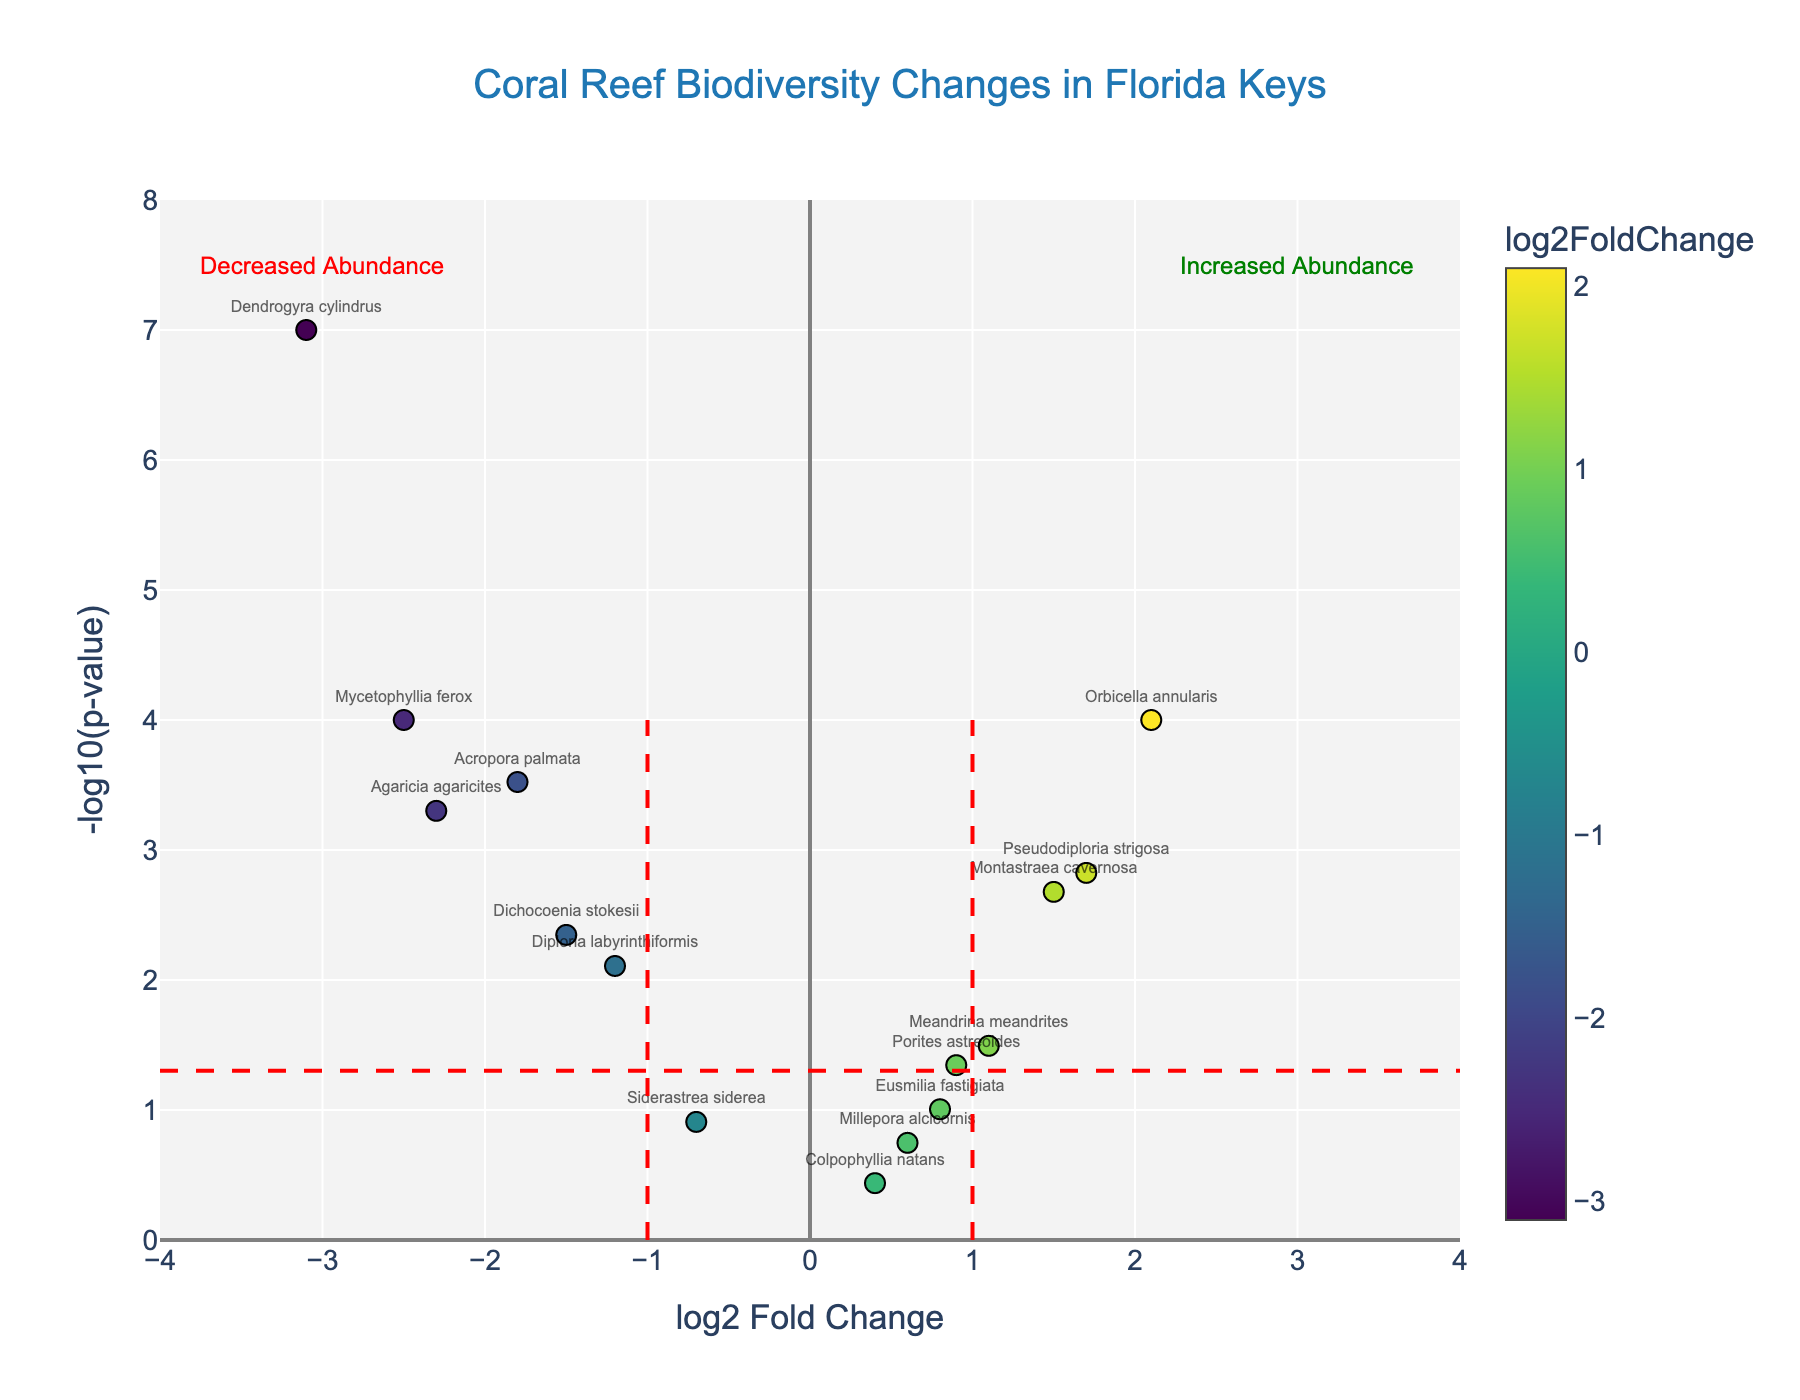What is the title of the figure? The title of the figure is typically located at the top and is displayed prominently to provide an overview of the subject being analyzed.
Answer: Coral Reef Biodiversity Changes in Florida Keys What is the log2 fold change value for Orbicella annularis? To find the log2 fold change value, locate the species 'Orbicella annularis' and refer to its corresponding log2FoldChange value.
Answer: 2.1 Which species has the highest -log10(p-value)? To determine the species with the highest -log10(p-value), identify the data point that reaches the highest point on the y-axis. In this case, the highest point on the y-axis indicates the most statistically significant p-value.
Answer: Dendrogyra cylindrus Which species shows a significant decrease in abundance? A significant decrease in abundance can be identified by looking to the left of the vertical line at log2FoldChange = -1 with a p-value less than 0.05. This would appear in the lower-left side of the plot.
Answer: Acropora palmata, Agaricia agaricites, Mycetophyllia ferox, Dichocoenia stokesii How many species show increased abundance with a log2 fold change greater than 1? Check the number of points to the right of the vertical line at log2FoldChange = 1 that are above the significance level line (-log10(0.05)).
Answer: 3 (Orbicella annularis, Montastraea cavernosa, Pseudodiploria strigosa) Which species has the lowest p-value, and what is it? Locate the species with the highest point on the y-axis representing the smallest p-value. The p-value is then calculated using the relation of p-value = 10^(-y) where y is the -log10(p-value).
Answer: Dendrogyra cylindrus, 0.0000001 What does the red dashed horizontal line represent? Identify the horizontal line's value on the y-axis where it intersects and understand its significance in the context of the plot. The red dashed horizontal line typically marks the significance level for p-values.
Answer: Significance threshold for p-value (0.05) Which species are annotated as having 'Increased Abundance' above the red dashed line at log2FoldChange = 1? Look for species above the significance threshold and to the right of the log2FoldChange = 1 line, indicating increased abundance.
Answer: Orbicella annularis, Montastraea cavernosa, Pseudodiploria strigosa 